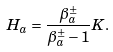<formula> <loc_0><loc_0><loc_500><loc_500>H _ { a } = \frac { \beta ^ { \pm } _ { a } } { \beta ^ { \pm } _ { a } - 1 } K .</formula> 